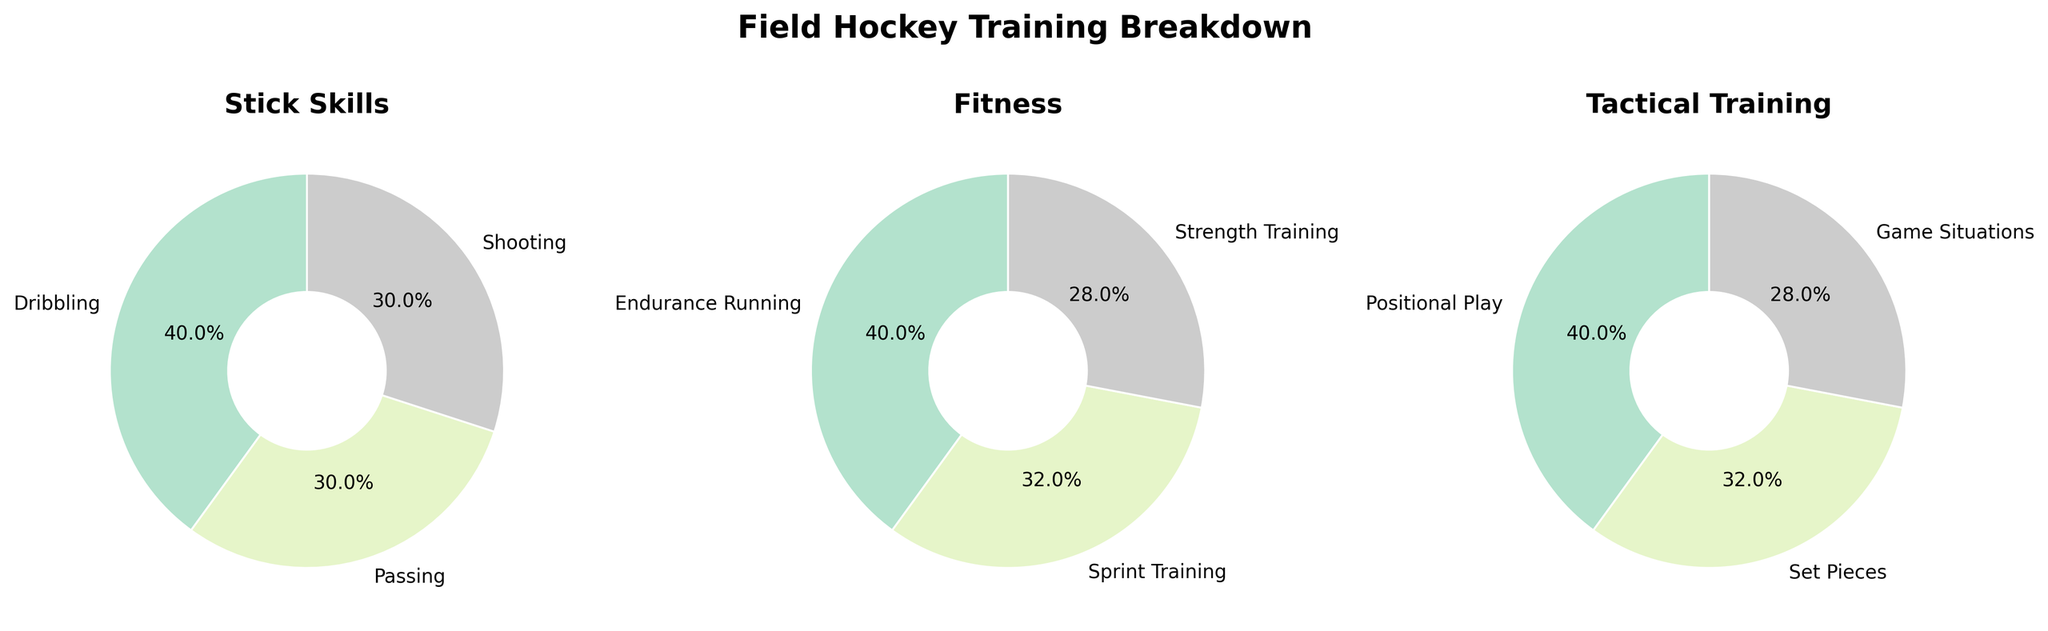What is the title of the figure? The title of the figure appears at the top, typically in larger and bold font. It's intended to give an overall summary of what the figure is about.
Answer: Field Hockey Training Breakdown How many categories are represented in the subplot of pie charts? By counting the number of pie charts, since each represents a category, we can determine the number of categories. Observing the subplot, there are three distinct pie charts.
Answer: 3 Which category has the highest number of activities? To determine this, we count the number of different activities listed in each pie chart. Stick Skills has 3 activities, Fitness has 3, and Tactical Training also has 3, meaning all categories have an equal number of activities.
Answer: All categories have 3 activities What percentage of training is allocated to Passing under Stick Skills? Refer to the pie chart labeled "Stick Skills" and look at the segment labeled "Passing." The percentage is displayed near the segment.
Answer: 15% Which Fitness activity has the smallest percentage allocation? Looking at the pie chart labeled "Fitness," locate the segments and their corresponding percentages. Sprint Training has the smallest segment with 8%.
Answer: Sprint Training What is the combined percentage of Dribbling and Shooting in Stick Skills? Find the percentages for Dribbling and Shooting in the Stick Skills pie chart. Dribbling is 20% and Shooting is 15%. Adding these two gives 20% + 15%.
Answer: 35% Which activity has an equal percentage allocation between Tactical Training and another category? Examine the segments in the Tactical Training pie chart, then compare their percentages with other categories. Both Set Pieces in Tactical Training and Sprint Training in Fitness are 8%.
Answer: Set Pieces and Sprint Training What is the difference in percentage allocation between Endurance Running and Shooting? Endurance Running in the Fitness category is 10%, while Shooting in the Stick Skills category is 15%. Calculate the difference as 15% - 10%.
Answer: 5% Which category allocates more percentage time to game-related activities? Compare the time percentages for "Game Situations" in Tactical Training (7%) with all activities in other categories. "Game Situations" have matching or smaller percentages compared to other activities.
Answer: Tactical Training 